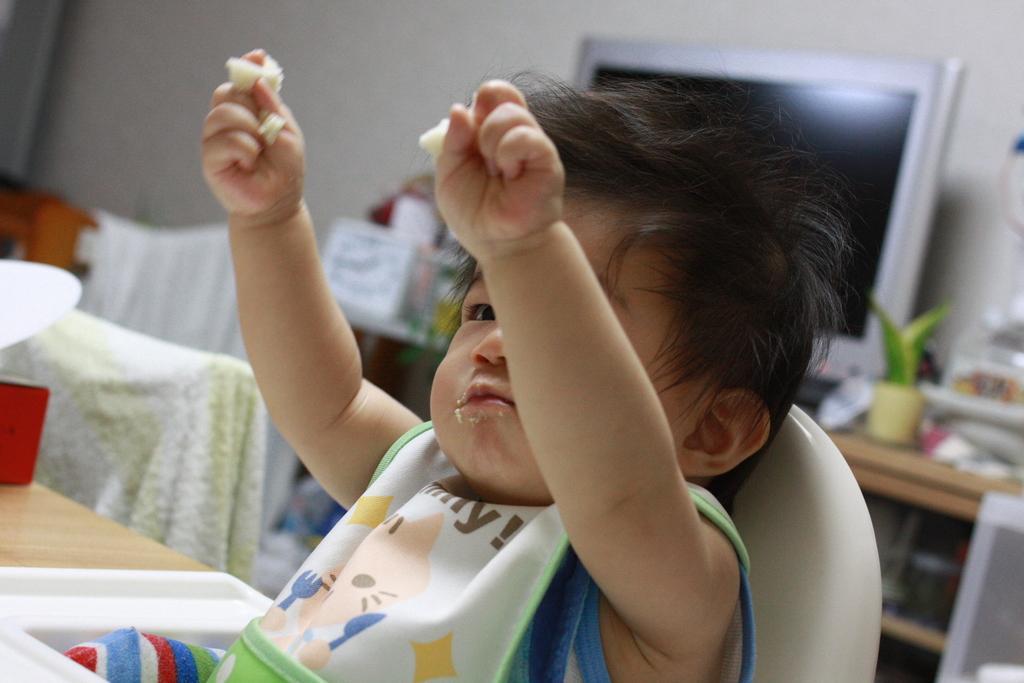Describe this image in one or two sentences. In this picture there is a kid sitting on a chair and holding food and we can see red object on the table and cloth. In the background of the image it is blurry and we can see monitor and objects on the table, cloth and wall. 